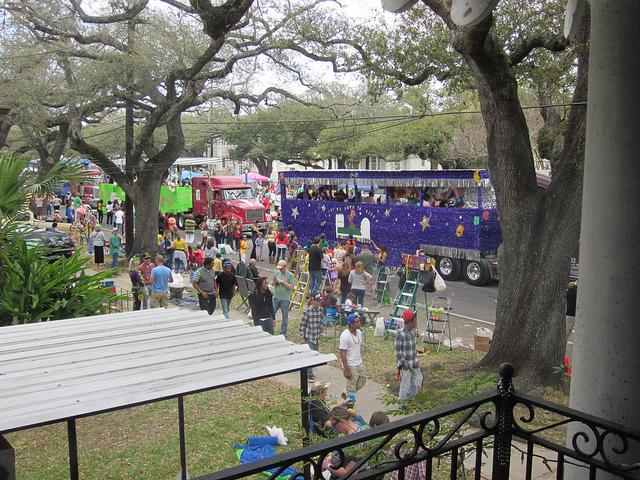Is the roof made of tin?
Be succinct. Yes. What are the people looking at it?
Quick response, please. Parade. What is the fence made of?
Answer briefly. Iron. What type are birds are pictured?
Write a very short answer. None. Is this a bench?
Keep it brief. No. 